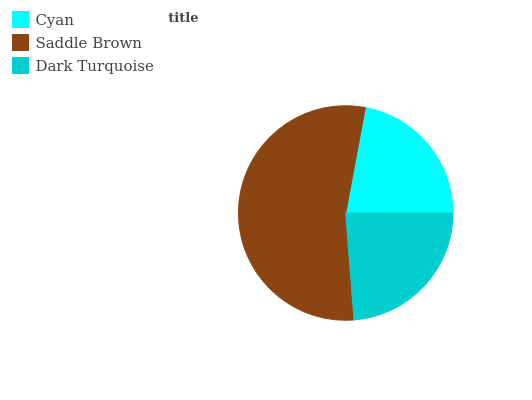Is Cyan the minimum?
Answer yes or no. Yes. Is Saddle Brown the maximum?
Answer yes or no. Yes. Is Dark Turquoise the minimum?
Answer yes or no. No. Is Dark Turquoise the maximum?
Answer yes or no. No. Is Saddle Brown greater than Dark Turquoise?
Answer yes or no. Yes. Is Dark Turquoise less than Saddle Brown?
Answer yes or no. Yes. Is Dark Turquoise greater than Saddle Brown?
Answer yes or no. No. Is Saddle Brown less than Dark Turquoise?
Answer yes or no. No. Is Dark Turquoise the high median?
Answer yes or no. Yes. Is Dark Turquoise the low median?
Answer yes or no. Yes. Is Cyan the high median?
Answer yes or no. No. Is Saddle Brown the low median?
Answer yes or no. No. 